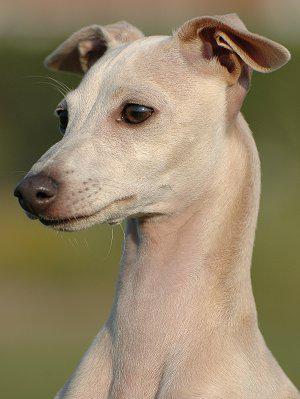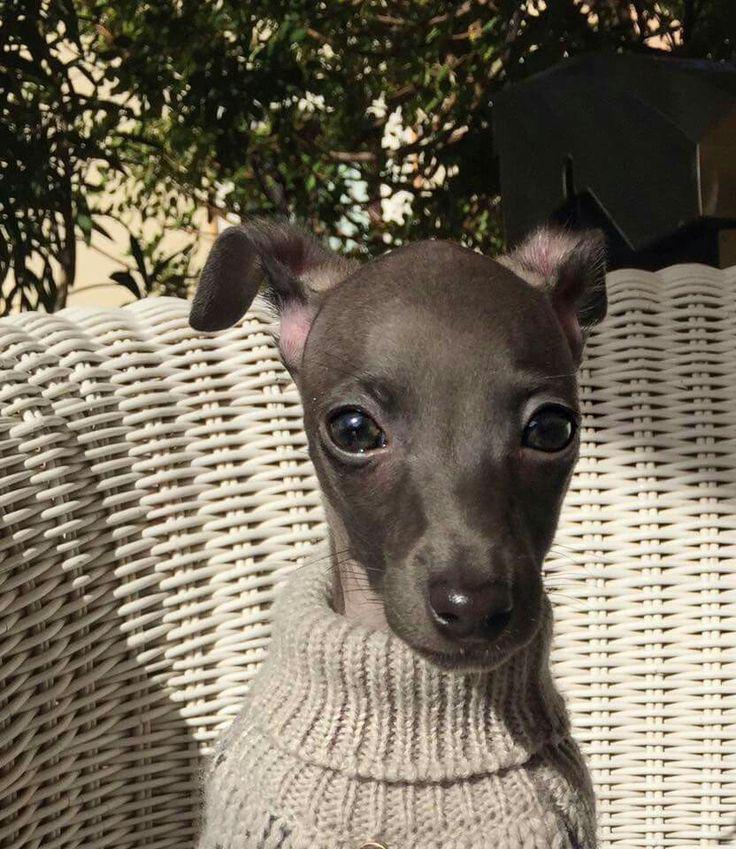The first image is the image on the left, the second image is the image on the right. Analyze the images presented: Is the assertion "An image shows one hound posed human-like, with upright head, facing the camera." valid? Answer yes or no. Yes. The first image is the image on the left, the second image is the image on the right. Given the left and right images, does the statement "One of the dogs is standing on all fours in the grass." hold true? Answer yes or no. No. 